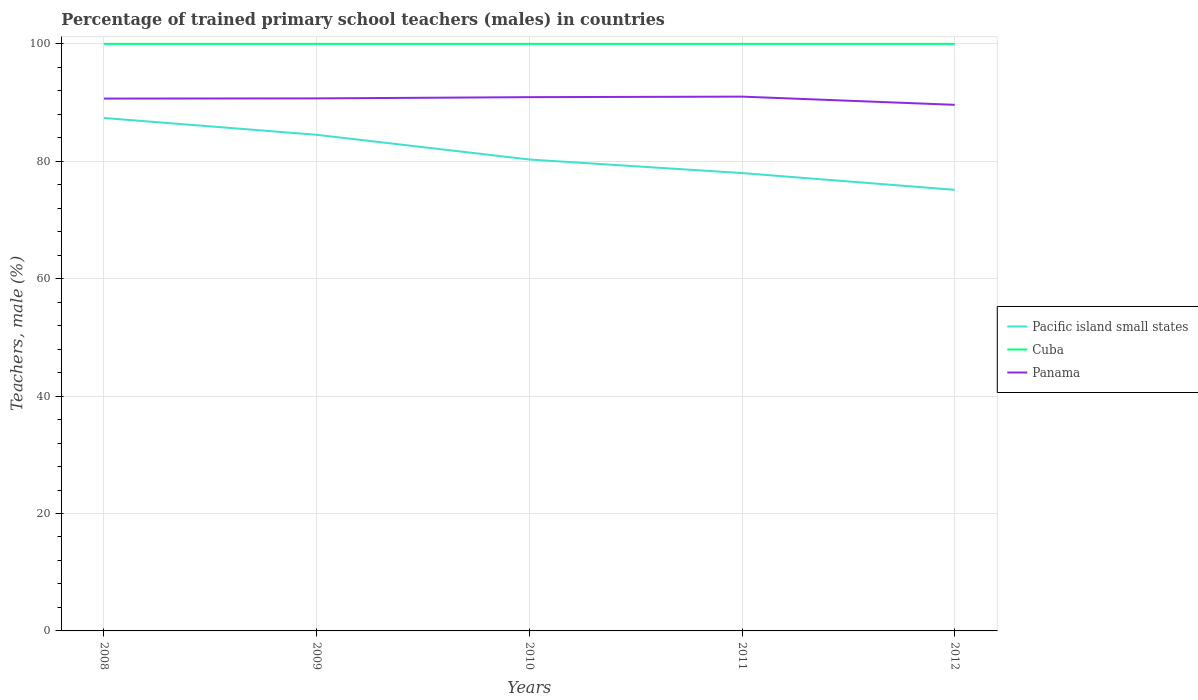How many different coloured lines are there?
Provide a succinct answer. 3. Across all years, what is the maximum percentage of trained primary school teachers (males) in Cuba?
Keep it short and to the point. 100. In which year was the percentage of trained primary school teachers (males) in Cuba maximum?
Your response must be concise. 2008. What is the difference between the highest and the second highest percentage of trained primary school teachers (males) in Panama?
Offer a terse response. 1.4. What is the difference between the highest and the lowest percentage of trained primary school teachers (males) in Cuba?
Keep it short and to the point. 0. Is the percentage of trained primary school teachers (males) in Cuba strictly greater than the percentage of trained primary school teachers (males) in Pacific island small states over the years?
Provide a succinct answer. No. Are the values on the major ticks of Y-axis written in scientific E-notation?
Give a very brief answer. No. How many legend labels are there?
Give a very brief answer. 3. What is the title of the graph?
Provide a succinct answer. Percentage of trained primary school teachers (males) in countries. Does "Central African Republic" appear as one of the legend labels in the graph?
Provide a short and direct response. No. What is the label or title of the Y-axis?
Your answer should be very brief. Teachers, male (%). What is the Teachers, male (%) of Pacific island small states in 2008?
Offer a terse response. 87.37. What is the Teachers, male (%) of Cuba in 2008?
Make the answer very short. 100. What is the Teachers, male (%) in Panama in 2008?
Your response must be concise. 90.68. What is the Teachers, male (%) in Pacific island small states in 2009?
Keep it short and to the point. 84.51. What is the Teachers, male (%) of Panama in 2009?
Ensure brevity in your answer.  90.71. What is the Teachers, male (%) of Pacific island small states in 2010?
Provide a succinct answer. 80.3. What is the Teachers, male (%) in Cuba in 2010?
Your answer should be compact. 100. What is the Teachers, male (%) of Panama in 2010?
Offer a very short reply. 90.92. What is the Teachers, male (%) in Pacific island small states in 2011?
Give a very brief answer. 77.99. What is the Teachers, male (%) of Panama in 2011?
Make the answer very short. 91.01. What is the Teachers, male (%) in Pacific island small states in 2012?
Keep it short and to the point. 75.14. What is the Teachers, male (%) of Panama in 2012?
Offer a terse response. 89.62. Across all years, what is the maximum Teachers, male (%) in Pacific island small states?
Offer a terse response. 87.37. Across all years, what is the maximum Teachers, male (%) in Panama?
Your answer should be compact. 91.01. Across all years, what is the minimum Teachers, male (%) in Pacific island small states?
Provide a succinct answer. 75.14. Across all years, what is the minimum Teachers, male (%) in Panama?
Your answer should be compact. 89.62. What is the total Teachers, male (%) in Pacific island small states in the graph?
Your answer should be very brief. 405.32. What is the total Teachers, male (%) in Cuba in the graph?
Ensure brevity in your answer.  500. What is the total Teachers, male (%) of Panama in the graph?
Keep it short and to the point. 452.95. What is the difference between the Teachers, male (%) in Pacific island small states in 2008 and that in 2009?
Your response must be concise. 2.86. What is the difference between the Teachers, male (%) in Panama in 2008 and that in 2009?
Offer a very short reply. -0.03. What is the difference between the Teachers, male (%) in Pacific island small states in 2008 and that in 2010?
Provide a succinct answer. 7.07. What is the difference between the Teachers, male (%) of Panama in 2008 and that in 2010?
Offer a very short reply. -0.24. What is the difference between the Teachers, male (%) in Pacific island small states in 2008 and that in 2011?
Provide a succinct answer. 9.38. What is the difference between the Teachers, male (%) of Cuba in 2008 and that in 2011?
Give a very brief answer. 0. What is the difference between the Teachers, male (%) of Panama in 2008 and that in 2011?
Your answer should be very brief. -0.33. What is the difference between the Teachers, male (%) of Pacific island small states in 2008 and that in 2012?
Keep it short and to the point. 12.24. What is the difference between the Teachers, male (%) of Panama in 2008 and that in 2012?
Ensure brevity in your answer.  1.06. What is the difference between the Teachers, male (%) of Pacific island small states in 2009 and that in 2010?
Ensure brevity in your answer.  4.21. What is the difference between the Teachers, male (%) of Panama in 2009 and that in 2010?
Your response must be concise. -0.21. What is the difference between the Teachers, male (%) of Pacific island small states in 2009 and that in 2011?
Provide a short and direct response. 6.52. What is the difference between the Teachers, male (%) in Panama in 2009 and that in 2011?
Your answer should be compact. -0.3. What is the difference between the Teachers, male (%) in Pacific island small states in 2009 and that in 2012?
Provide a succinct answer. 9.37. What is the difference between the Teachers, male (%) of Panama in 2009 and that in 2012?
Give a very brief answer. 1.1. What is the difference between the Teachers, male (%) in Pacific island small states in 2010 and that in 2011?
Ensure brevity in your answer.  2.31. What is the difference between the Teachers, male (%) in Panama in 2010 and that in 2011?
Offer a terse response. -0.09. What is the difference between the Teachers, male (%) of Pacific island small states in 2010 and that in 2012?
Ensure brevity in your answer.  5.17. What is the difference between the Teachers, male (%) in Panama in 2010 and that in 2012?
Offer a terse response. 1.31. What is the difference between the Teachers, male (%) of Pacific island small states in 2011 and that in 2012?
Offer a terse response. 2.86. What is the difference between the Teachers, male (%) of Panama in 2011 and that in 2012?
Provide a short and direct response. 1.4. What is the difference between the Teachers, male (%) in Pacific island small states in 2008 and the Teachers, male (%) in Cuba in 2009?
Ensure brevity in your answer.  -12.63. What is the difference between the Teachers, male (%) in Pacific island small states in 2008 and the Teachers, male (%) in Panama in 2009?
Make the answer very short. -3.34. What is the difference between the Teachers, male (%) of Cuba in 2008 and the Teachers, male (%) of Panama in 2009?
Your response must be concise. 9.29. What is the difference between the Teachers, male (%) of Pacific island small states in 2008 and the Teachers, male (%) of Cuba in 2010?
Keep it short and to the point. -12.63. What is the difference between the Teachers, male (%) of Pacific island small states in 2008 and the Teachers, male (%) of Panama in 2010?
Provide a succinct answer. -3.55. What is the difference between the Teachers, male (%) of Cuba in 2008 and the Teachers, male (%) of Panama in 2010?
Your answer should be very brief. 9.08. What is the difference between the Teachers, male (%) of Pacific island small states in 2008 and the Teachers, male (%) of Cuba in 2011?
Ensure brevity in your answer.  -12.63. What is the difference between the Teachers, male (%) of Pacific island small states in 2008 and the Teachers, male (%) of Panama in 2011?
Offer a terse response. -3.64. What is the difference between the Teachers, male (%) in Cuba in 2008 and the Teachers, male (%) in Panama in 2011?
Your response must be concise. 8.99. What is the difference between the Teachers, male (%) of Pacific island small states in 2008 and the Teachers, male (%) of Cuba in 2012?
Ensure brevity in your answer.  -12.63. What is the difference between the Teachers, male (%) of Pacific island small states in 2008 and the Teachers, male (%) of Panama in 2012?
Your answer should be very brief. -2.24. What is the difference between the Teachers, male (%) of Cuba in 2008 and the Teachers, male (%) of Panama in 2012?
Make the answer very short. 10.38. What is the difference between the Teachers, male (%) of Pacific island small states in 2009 and the Teachers, male (%) of Cuba in 2010?
Offer a terse response. -15.49. What is the difference between the Teachers, male (%) in Pacific island small states in 2009 and the Teachers, male (%) in Panama in 2010?
Offer a very short reply. -6.41. What is the difference between the Teachers, male (%) in Cuba in 2009 and the Teachers, male (%) in Panama in 2010?
Make the answer very short. 9.08. What is the difference between the Teachers, male (%) of Pacific island small states in 2009 and the Teachers, male (%) of Cuba in 2011?
Your answer should be compact. -15.49. What is the difference between the Teachers, male (%) of Pacific island small states in 2009 and the Teachers, male (%) of Panama in 2011?
Ensure brevity in your answer.  -6.5. What is the difference between the Teachers, male (%) of Cuba in 2009 and the Teachers, male (%) of Panama in 2011?
Give a very brief answer. 8.99. What is the difference between the Teachers, male (%) of Pacific island small states in 2009 and the Teachers, male (%) of Cuba in 2012?
Provide a short and direct response. -15.49. What is the difference between the Teachers, male (%) in Pacific island small states in 2009 and the Teachers, male (%) in Panama in 2012?
Make the answer very short. -5.11. What is the difference between the Teachers, male (%) in Cuba in 2009 and the Teachers, male (%) in Panama in 2012?
Your response must be concise. 10.38. What is the difference between the Teachers, male (%) of Pacific island small states in 2010 and the Teachers, male (%) of Cuba in 2011?
Ensure brevity in your answer.  -19.7. What is the difference between the Teachers, male (%) in Pacific island small states in 2010 and the Teachers, male (%) in Panama in 2011?
Provide a succinct answer. -10.71. What is the difference between the Teachers, male (%) in Cuba in 2010 and the Teachers, male (%) in Panama in 2011?
Your response must be concise. 8.99. What is the difference between the Teachers, male (%) of Pacific island small states in 2010 and the Teachers, male (%) of Cuba in 2012?
Provide a succinct answer. -19.7. What is the difference between the Teachers, male (%) of Pacific island small states in 2010 and the Teachers, male (%) of Panama in 2012?
Your answer should be very brief. -9.31. What is the difference between the Teachers, male (%) in Cuba in 2010 and the Teachers, male (%) in Panama in 2012?
Provide a short and direct response. 10.38. What is the difference between the Teachers, male (%) in Pacific island small states in 2011 and the Teachers, male (%) in Cuba in 2012?
Your answer should be compact. -22.01. What is the difference between the Teachers, male (%) of Pacific island small states in 2011 and the Teachers, male (%) of Panama in 2012?
Provide a succinct answer. -11.62. What is the difference between the Teachers, male (%) in Cuba in 2011 and the Teachers, male (%) in Panama in 2012?
Provide a short and direct response. 10.38. What is the average Teachers, male (%) in Pacific island small states per year?
Provide a succinct answer. 81.06. What is the average Teachers, male (%) of Panama per year?
Provide a short and direct response. 90.59. In the year 2008, what is the difference between the Teachers, male (%) in Pacific island small states and Teachers, male (%) in Cuba?
Your answer should be very brief. -12.63. In the year 2008, what is the difference between the Teachers, male (%) in Pacific island small states and Teachers, male (%) in Panama?
Ensure brevity in your answer.  -3.31. In the year 2008, what is the difference between the Teachers, male (%) in Cuba and Teachers, male (%) in Panama?
Provide a succinct answer. 9.32. In the year 2009, what is the difference between the Teachers, male (%) in Pacific island small states and Teachers, male (%) in Cuba?
Offer a terse response. -15.49. In the year 2009, what is the difference between the Teachers, male (%) in Pacific island small states and Teachers, male (%) in Panama?
Ensure brevity in your answer.  -6.2. In the year 2009, what is the difference between the Teachers, male (%) of Cuba and Teachers, male (%) of Panama?
Give a very brief answer. 9.29. In the year 2010, what is the difference between the Teachers, male (%) in Pacific island small states and Teachers, male (%) in Cuba?
Make the answer very short. -19.7. In the year 2010, what is the difference between the Teachers, male (%) in Pacific island small states and Teachers, male (%) in Panama?
Provide a short and direct response. -10.62. In the year 2010, what is the difference between the Teachers, male (%) of Cuba and Teachers, male (%) of Panama?
Keep it short and to the point. 9.08. In the year 2011, what is the difference between the Teachers, male (%) of Pacific island small states and Teachers, male (%) of Cuba?
Give a very brief answer. -22.01. In the year 2011, what is the difference between the Teachers, male (%) of Pacific island small states and Teachers, male (%) of Panama?
Ensure brevity in your answer.  -13.02. In the year 2011, what is the difference between the Teachers, male (%) in Cuba and Teachers, male (%) in Panama?
Make the answer very short. 8.99. In the year 2012, what is the difference between the Teachers, male (%) of Pacific island small states and Teachers, male (%) of Cuba?
Your answer should be compact. -24.86. In the year 2012, what is the difference between the Teachers, male (%) of Pacific island small states and Teachers, male (%) of Panama?
Your response must be concise. -14.48. In the year 2012, what is the difference between the Teachers, male (%) of Cuba and Teachers, male (%) of Panama?
Your response must be concise. 10.38. What is the ratio of the Teachers, male (%) in Pacific island small states in 2008 to that in 2009?
Your answer should be very brief. 1.03. What is the ratio of the Teachers, male (%) in Panama in 2008 to that in 2009?
Your response must be concise. 1. What is the ratio of the Teachers, male (%) of Pacific island small states in 2008 to that in 2010?
Keep it short and to the point. 1.09. What is the ratio of the Teachers, male (%) in Cuba in 2008 to that in 2010?
Offer a terse response. 1. What is the ratio of the Teachers, male (%) of Panama in 2008 to that in 2010?
Offer a terse response. 1. What is the ratio of the Teachers, male (%) of Pacific island small states in 2008 to that in 2011?
Provide a succinct answer. 1.12. What is the ratio of the Teachers, male (%) in Panama in 2008 to that in 2011?
Your answer should be compact. 1. What is the ratio of the Teachers, male (%) in Pacific island small states in 2008 to that in 2012?
Provide a short and direct response. 1.16. What is the ratio of the Teachers, male (%) in Panama in 2008 to that in 2012?
Give a very brief answer. 1.01. What is the ratio of the Teachers, male (%) of Pacific island small states in 2009 to that in 2010?
Your answer should be compact. 1.05. What is the ratio of the Teachers, male (%) in Cuba in 2009 to that in 2010?
Offer a very short reply. 1. What is the ratio of the Teachers, male (%) of Panama in 2009 to that in 2010?
Make the answer very short. 1. What is the ratio of the Teachers, male (%) of Pacific island small states in 2009 to that in 2011?
Your answer should be very brief. 1.08. What is the ratio of the Teachers, male (%) of Pacific island small states in 2009 to that in 2012?
Give a very brief answer. 1.12. What is the ratio of the Teachers, male (%) of Cuba in 2009 to that in 2012?
Your answer should be very brief. 1. What is the ratio of the Teachers, male (%) of Panama in 2009 to that in 2012?
Ensure brevity in your answer.  1.01. What is the ratio of the Teachers, male (%) of Pacific island small states in 2010 to that in 2011?
Give a very brief answer. 1.03. What is the ratio of the Teachers, male (%) of Panama in 2010 to that in 2011?
Offer a very short reply. 1. What is the ratio of the Teachers, male (%) of Pacific island small states in 2010 to that in 2012?
Provide a short and direct response. 1.07. What is the ratio of the Teachers, male (%) in Cuba in 2010 to that in 2012?
Provide a succinct answer. 1. What is the ratio of the Teachers, male (%) of Panama in 2010 to that in 2012?
Your answer should be compact. 1.01. What is the ratio of the Teachers, male (%) of Pacific island small states in 2011 to that in 2012?
Provide a short and direct response. 1.04. What is the ratio of the Teachers, male (%) in Panama in 2011 to that in 2012?
Offer a terse response. 1.02. What is the difference between the highest and the second highest Teachers, male (%) in Pacific island small states?
Offer a very short reply. 2.86. What is the difference between the highest and the second highest Teachers, male (%) of Cuba?
Give a very brief answer. 0. What is the difference between the highest and the second highest Teachers, male (%) of Panama?
Provide a short and direct response. 0.09. What is the difference between the highest and the lowest Teachers, male (%) in Pacific island small states?
Give a very brief answer. 12.24. What is the difference between the highest and the lowest Teachers, male (%) in Cuba?
Keep it short and to the point. 0. What is the difference between the highest and the lowest Teachers, male (%) of Panama?
Your answer should be very brief. 1.4. 